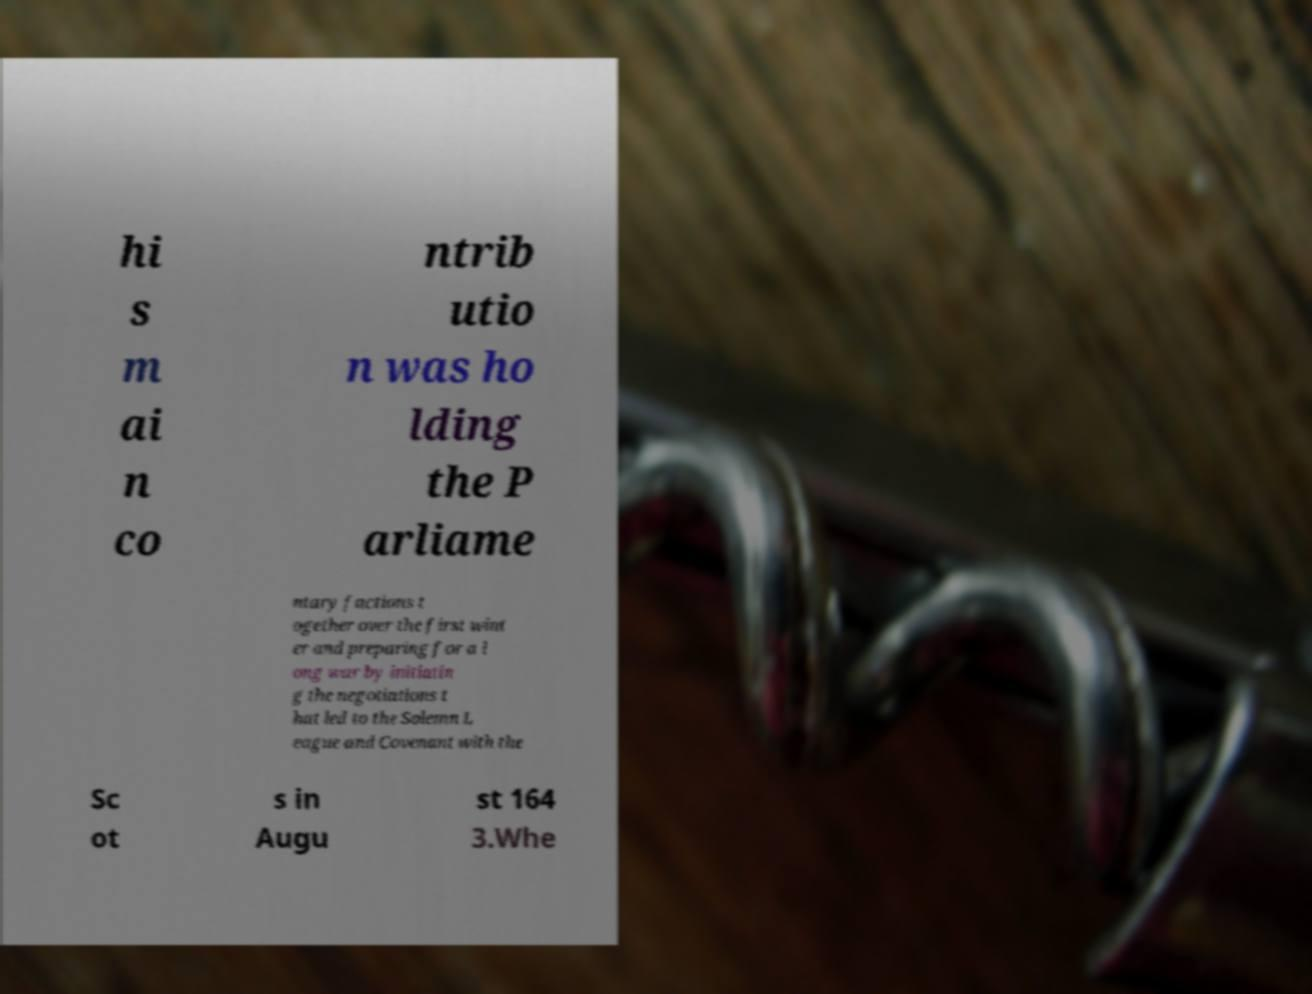For documentation purposes, I need the text within this image transcribed. Could you provide that? hi s m ai n co ntrib utio n was ho lding the P arliame ntary factions t ogether over the first wint er and preparing for a l ong war by initiatin g the negotiations t hat led to the Solemn L eague and Covenant with the Sc ot s in Augu st 164 3.Whe 